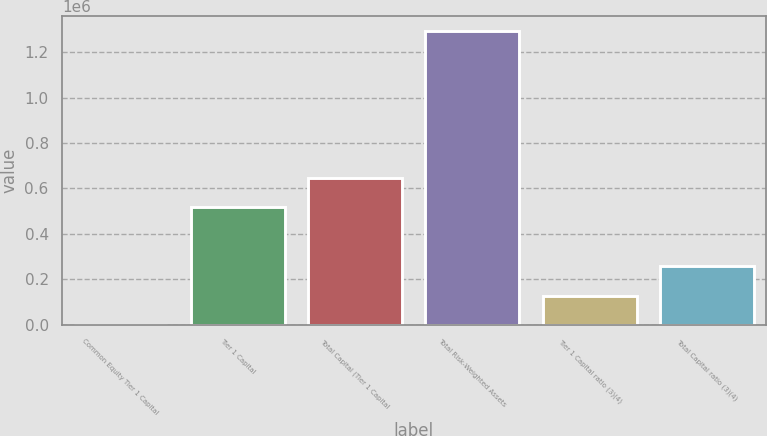<chart> <loc_0><loc_0><loc_500><loc_500><bar_chart><fcel>Common Equity Tier 1 Capital<fcel>Tier 1 Capital<fcel>Total Capital (Tier 1 Capital<fcel>Total Risk-Weighted Assets<fcel>Tier 1 Capital ratio (3)(4)<fcel>Total Capital ratio (3)(4)<nl><fcel>10.57<fcel>517048<fcel>646308<fcel>1.2926e+06<fcel>129270<fcel>258529<nl></chart> 